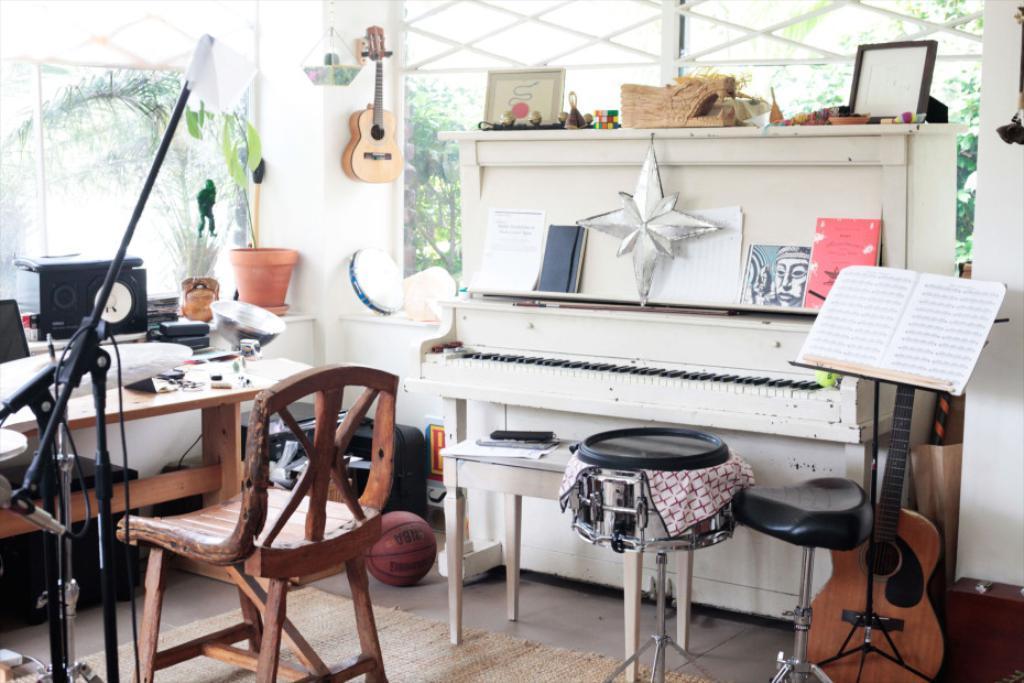Could you give a brief overview of what you see in this image? In this there is a room where we can see a guitar, a piano, frames and some objects at the top of the piano table, few objects on the table and on the wall, few books in which one of them is on one the stands, a flower pot, there is a basketball and black color objects on the floor, a floor mat, glass windows, outside the room there are few trees. 